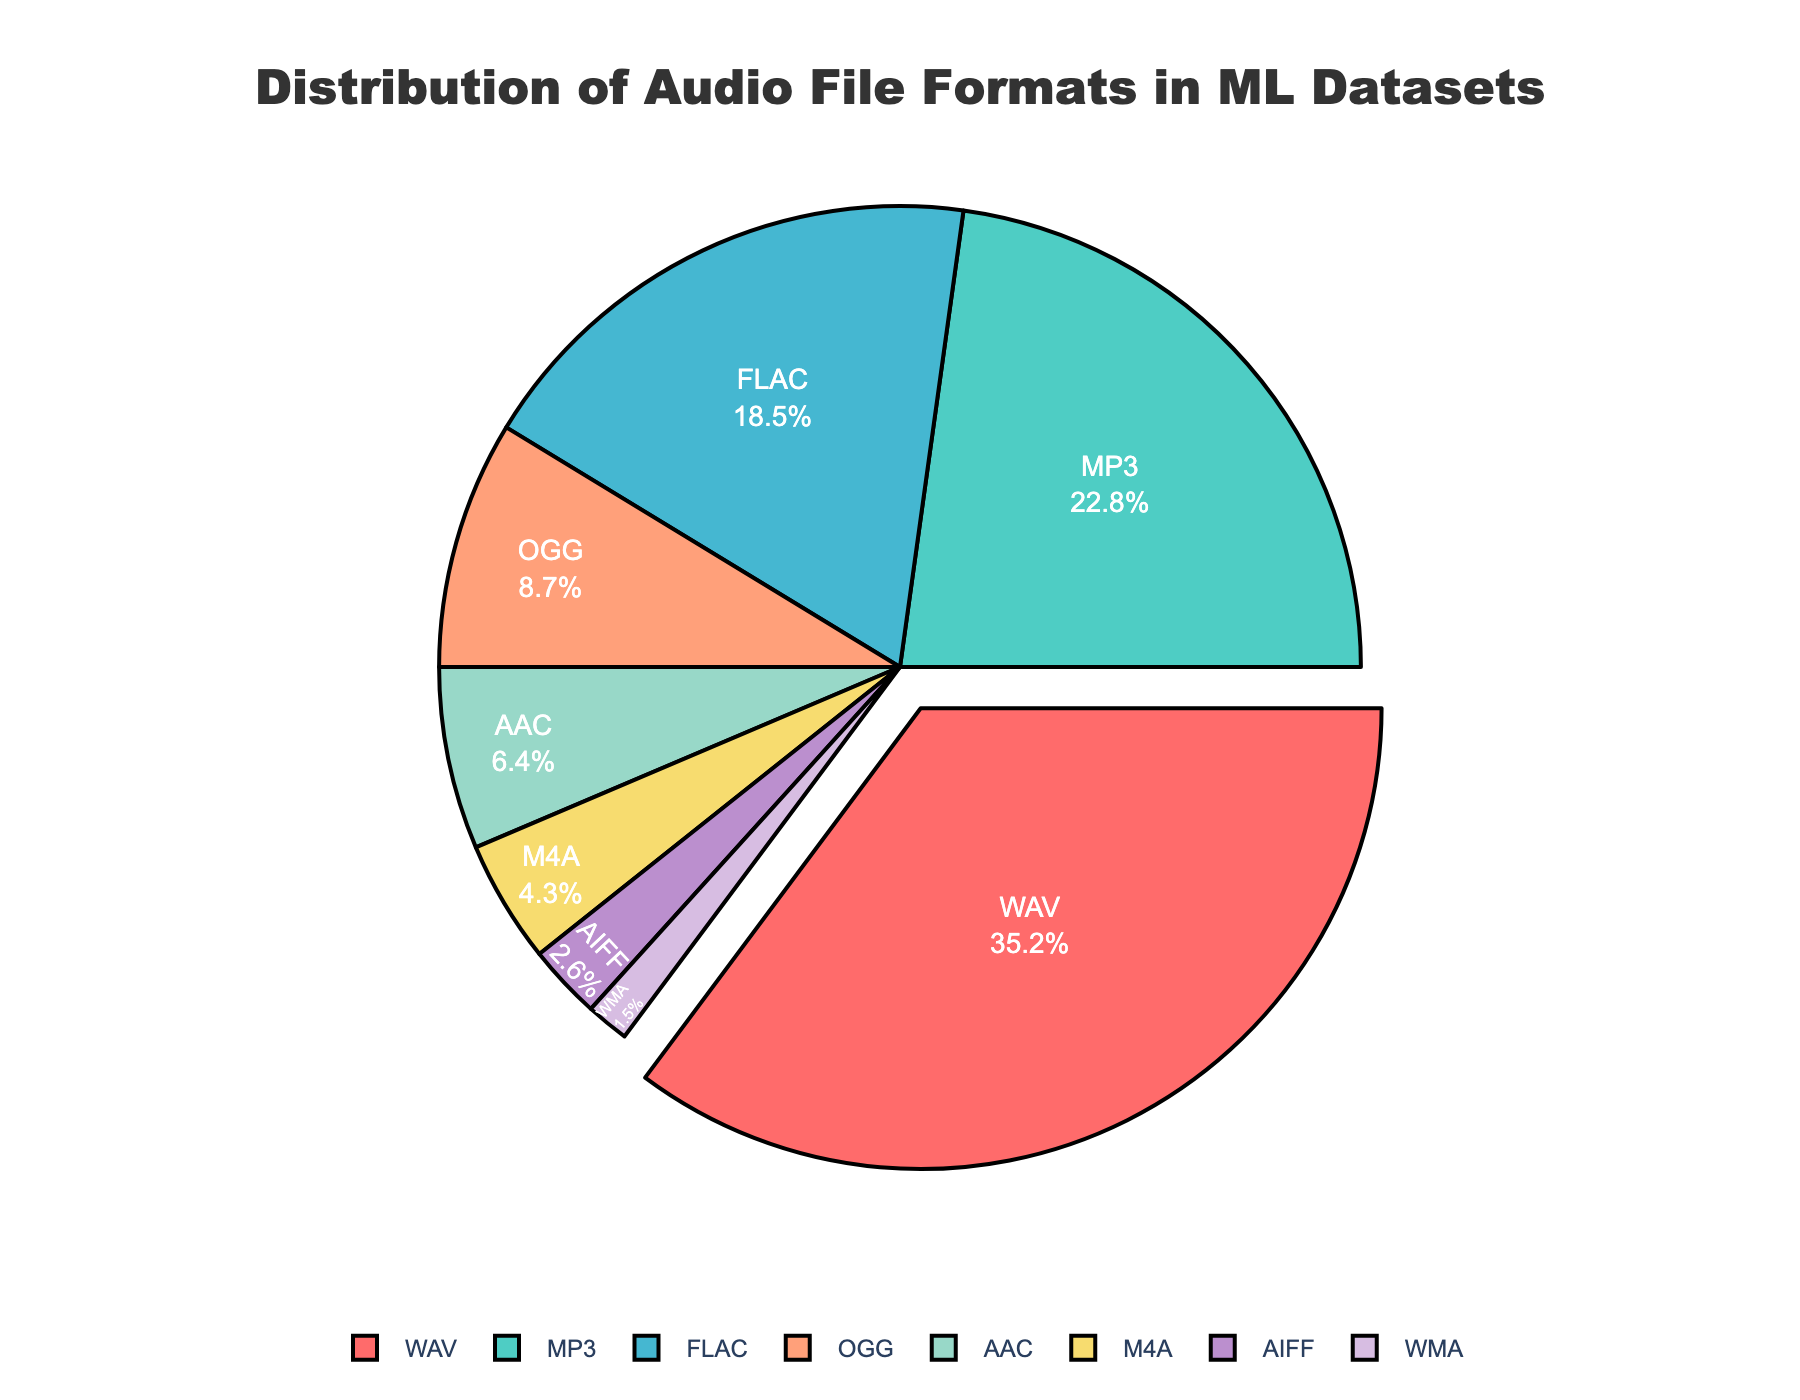What is the most common audio file format in machine learning datasets? The figure shows a pie chart with various audio file formats and their corresponding percentages. The largest segment is highlighted and marked with 35.2%, representing the WAV format.
Answer: WAV Which audio file format has the smallest share in the distribution? The smallest segment in the pie chart corresponds to the WMA format, with a percentage of 1.5%.
Answer: WMA How much more common is the WAV format compared to the AAC format? The pie chart shows that the WAV format accounts for 35.2% and the AAC format accounts for 6.4%. Subtracting these values gives 35.2% - 6.4% = 28.8%.
Answer: 28.8% What percentage of the data is in MP3 and FLAC formats combined? According to the pie chart, the MP3 format represents 22.8% and the FLAC format represents 18.5%. Adding these together gives 22.8% + 18.5% = 41.3%.
Answer: 41.3% Which color corresponds to the OGG format in the pie chart? The OGG format is denoted by a yellowish segment in the pie chart.
Answer: Yellowish (golden) Is the FLAC format more prevalent than the AAC and AIFF formats combined? The FLAC format accounts for 18.5% of the distribution. The AAC format is 6.4% and the AIFF format is 2.6%. Summing AAC and AIFF gives 6.4% + 2.6% = 9%. Since 18.5% is greater than 9%, FLAC is more prevalent.
Answer: Yes Which format is represented by purple in the pie chart? The AIFF format is marked with a purple segment.
Answer: AIFF 